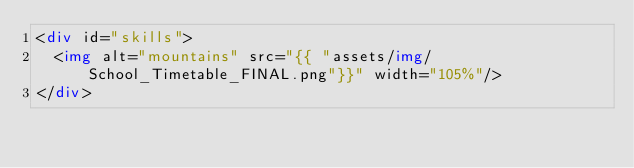<code> <loc_0><loc_0><loc_500><loc_500><_HTML_><div id="skills">
  <img alt="mountains" src="{{ "assets/img/School_Timetable_FINAL.png"}}" width="105%"/>
</div>
</code> 